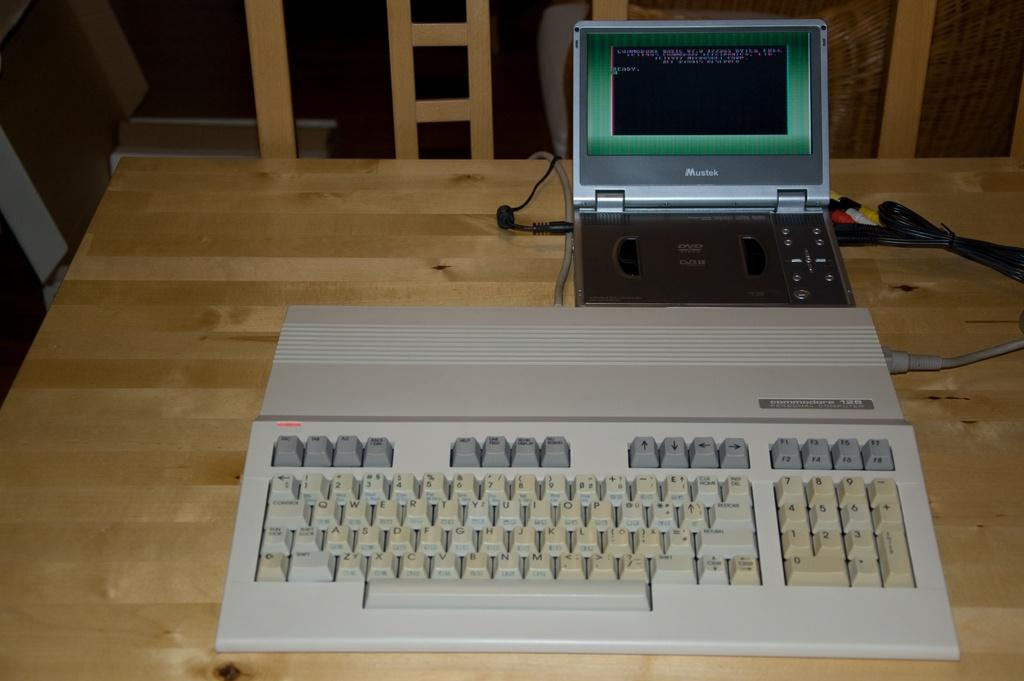<image>
Offer a succinct explanation of the picture presented. Old keyboard that has the word "Commodore" on the top and the numbers 128. 